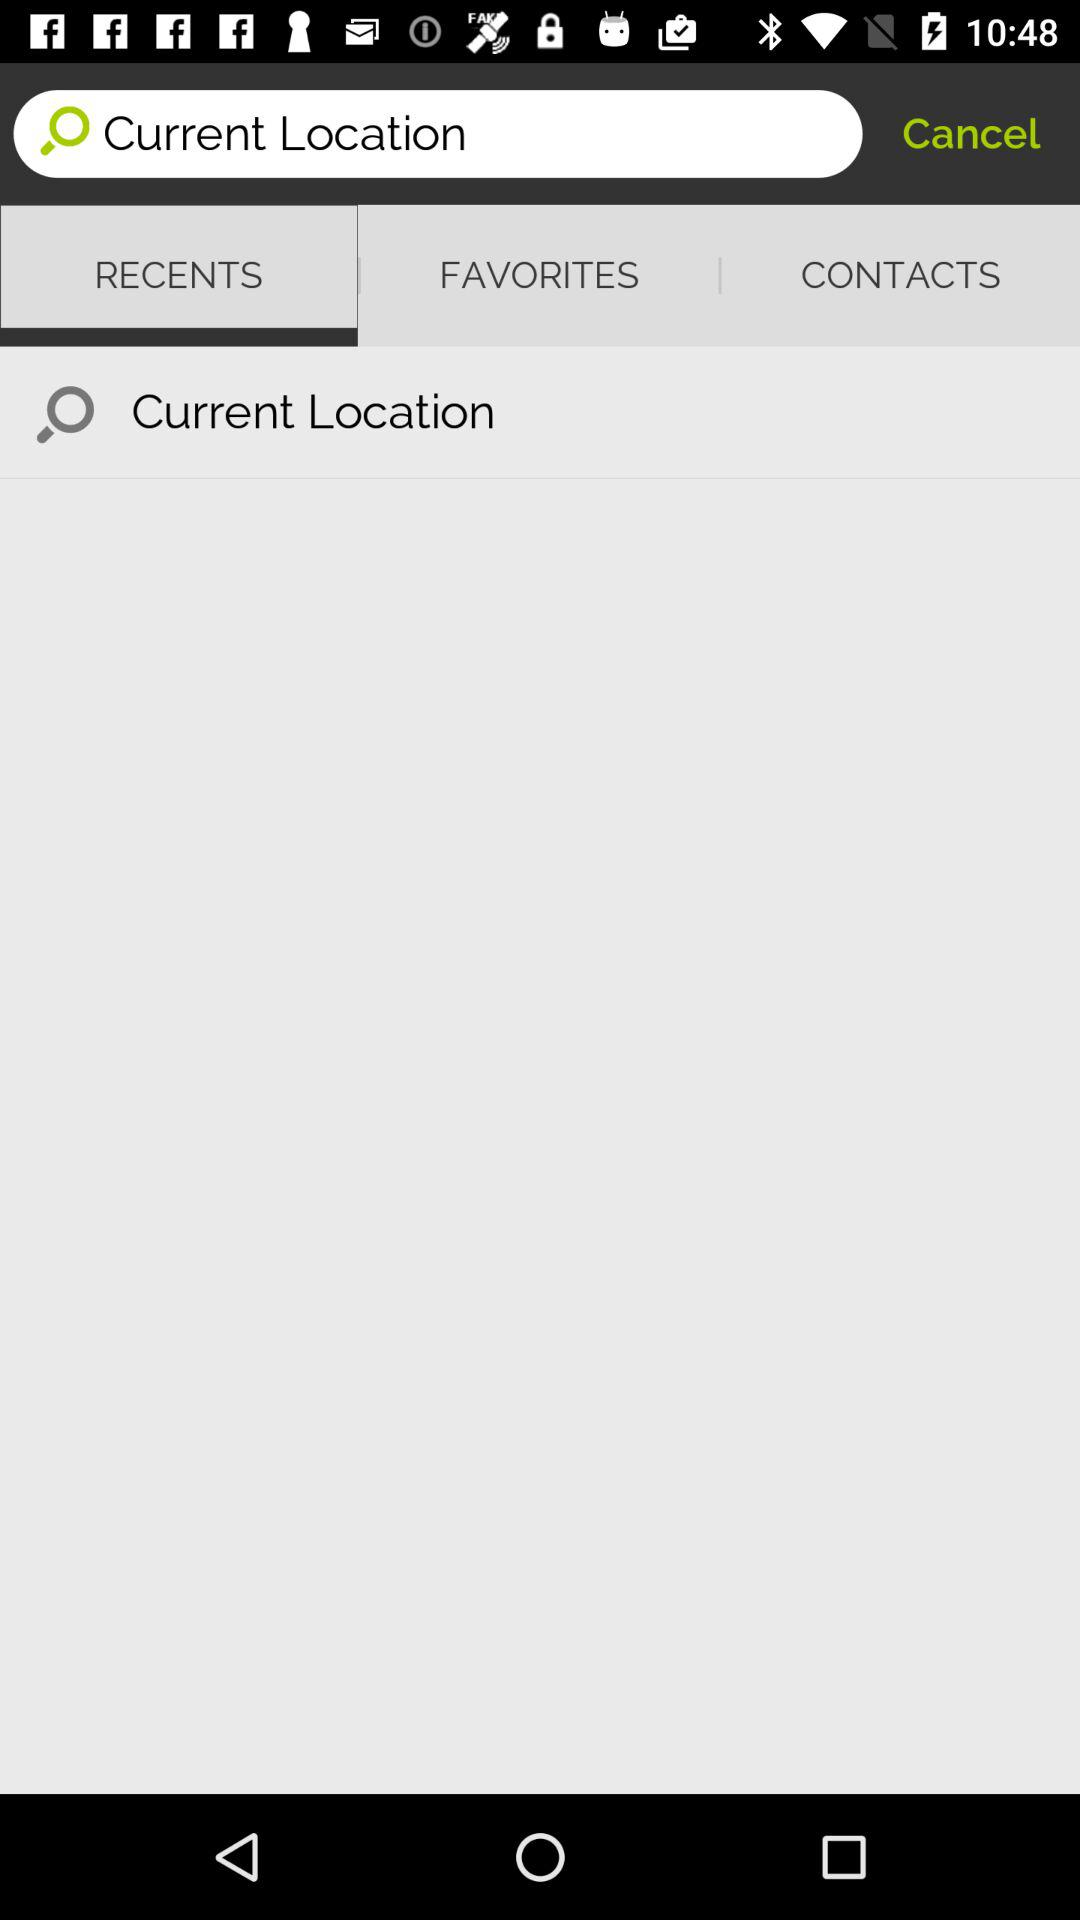Which tab is selected? The tab "RECENTS" is selected. 